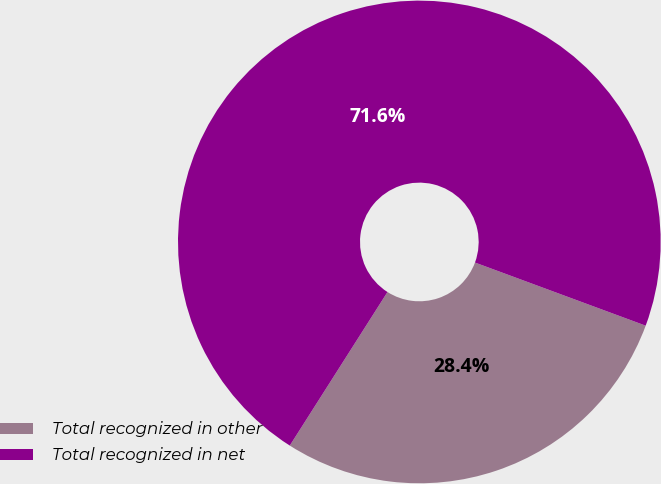Convert chart to OTSL. <chart><loc_0><loc_0><loc_500><loc_500><pie_chart><fcel>Total recognized in other<fcel>Total recognized in net<nl><fcel>28.38%<fcel>71.62%<nl></chart> 